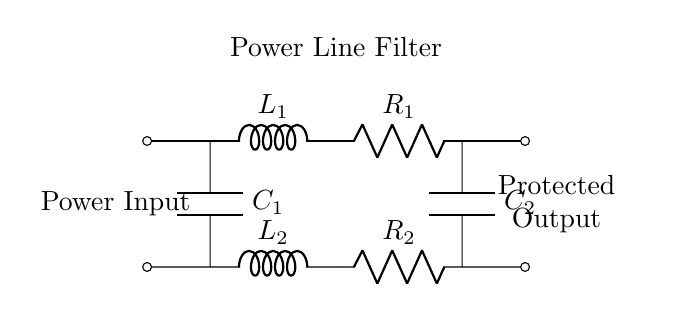What type of components are used in this circuit? The circuit contains inductors (L), resistors (R), and capacitors (C). Specifically, L1, R1, C1, L2, R2, and C2 are all present.
Answer: inductors, resistors, capacitors What is the purpose of the filter in this circuit? The filter is designed to protect sensitive electronic equipment from voltage fluctuations by filtering out electrical noise and transients.
Answer: voltage protection How many inductors are in the circuit? There are two inductors: L1 and L2. Each contributes to the filtering effect of the circuit.
Answer: two What is connected at the power input? The power input is connected to inductors and capacitors which are part of the filtering process. They help manage voltage fluctuations entering the equipment.
Answer: inductors and capacitors What does C1 and C2 represent in this filter? C1 and C2 are capacitors that help smooth out voltage fluctuations and stabilize the power supply to the connected equipment.
Answer: capacitors for smoothing How do the resistors R1 and R2 affect the circuit? R1 and R2 are used to limit the current flowing through the circuit and help in dissipating any unwanted power, contributing to the overall effectiveness of the filter.
Answer: current limiting and power dissipation What is the layout significance of L1 and L2 in this design? L1 and L2 are arranged in a way that they work together with the capacitors to create a low-pass filter effect, allowing only desired frequencies to pass through while blocking higher frequencies.
Answer: low-pass filter arrangement 